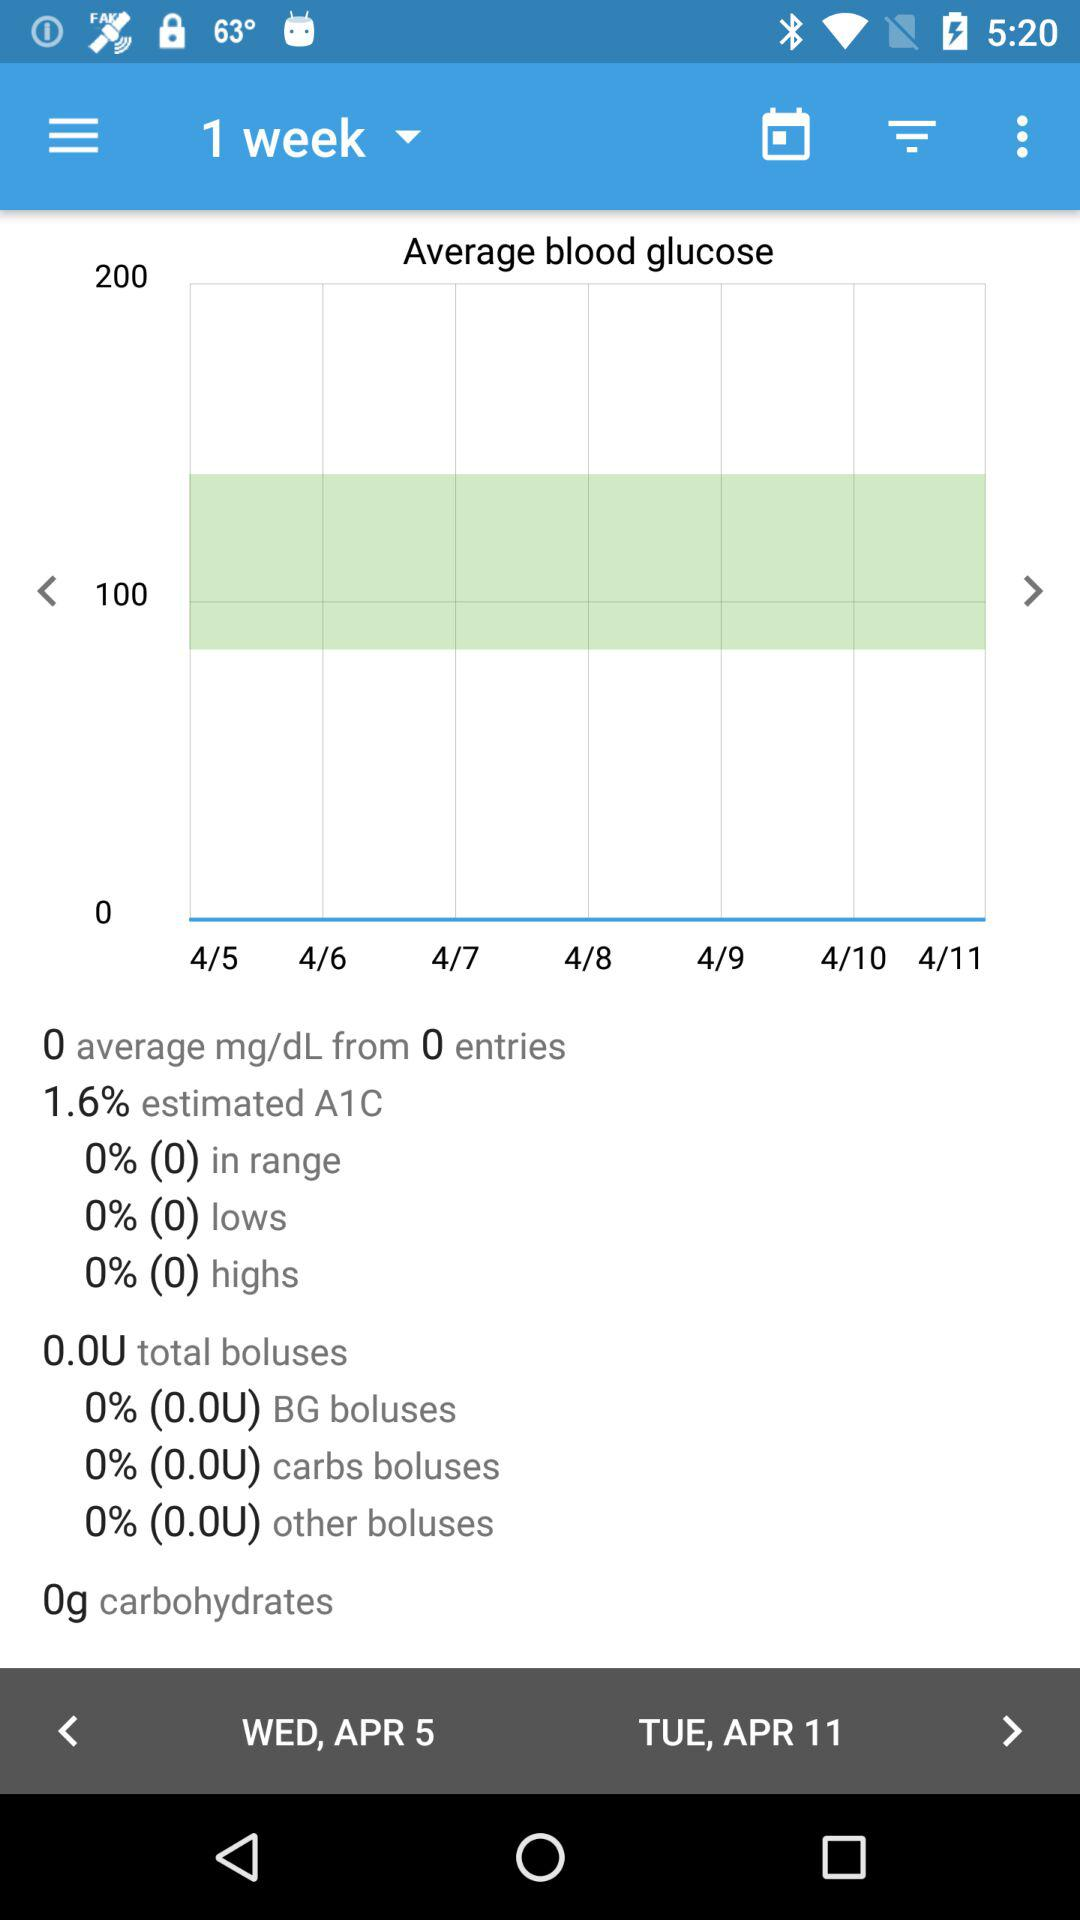What is the total number of boluses? The total number of boluses is 0 units. 